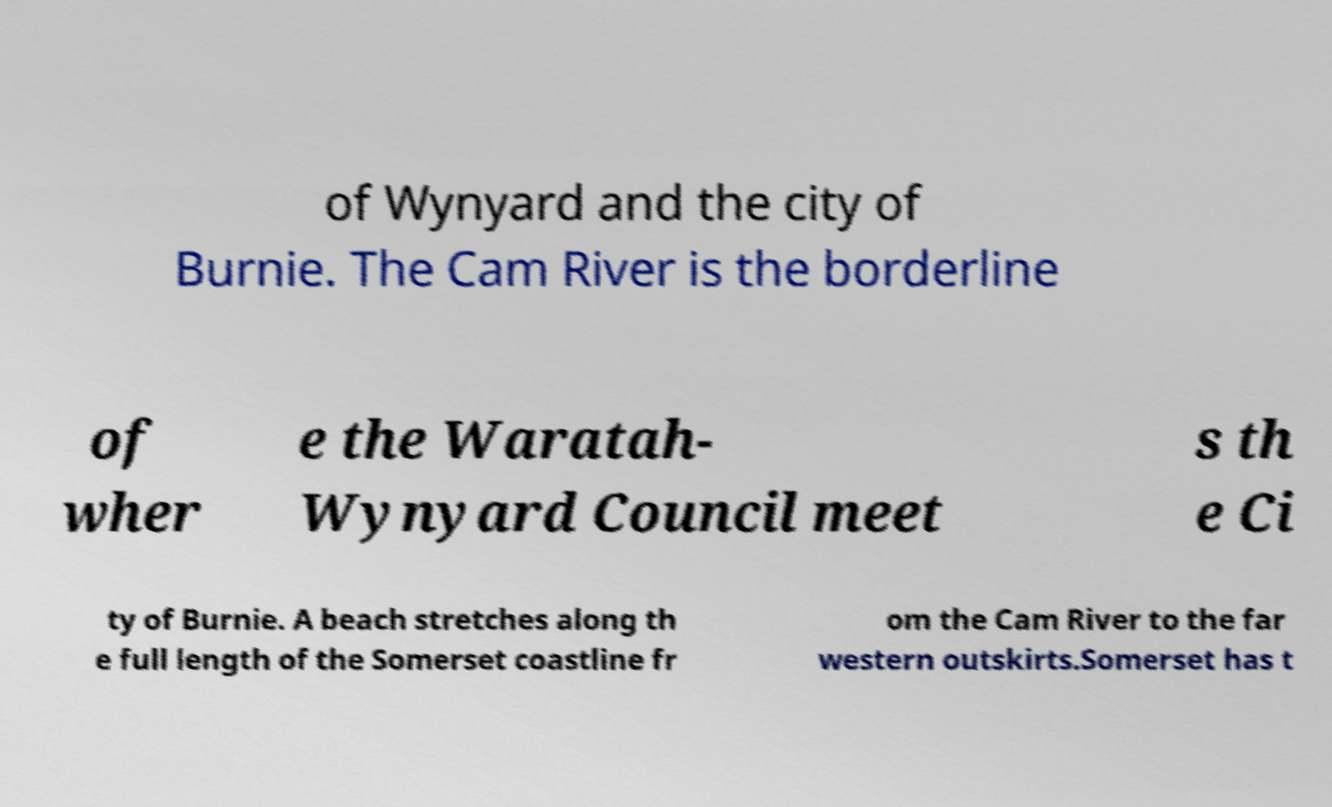What messages or text are displayed in this image? I need them in a readable, typed format. of Wynyard and the city of Burnie. The Cam River is the borderline of wher e the Waratah- Wynyard Council meet s th e Ci ty of Burnie. A beach stretches along th e full length of the Somerset coastline fr om the Cam River to the far western outskirts.Somerset has t 